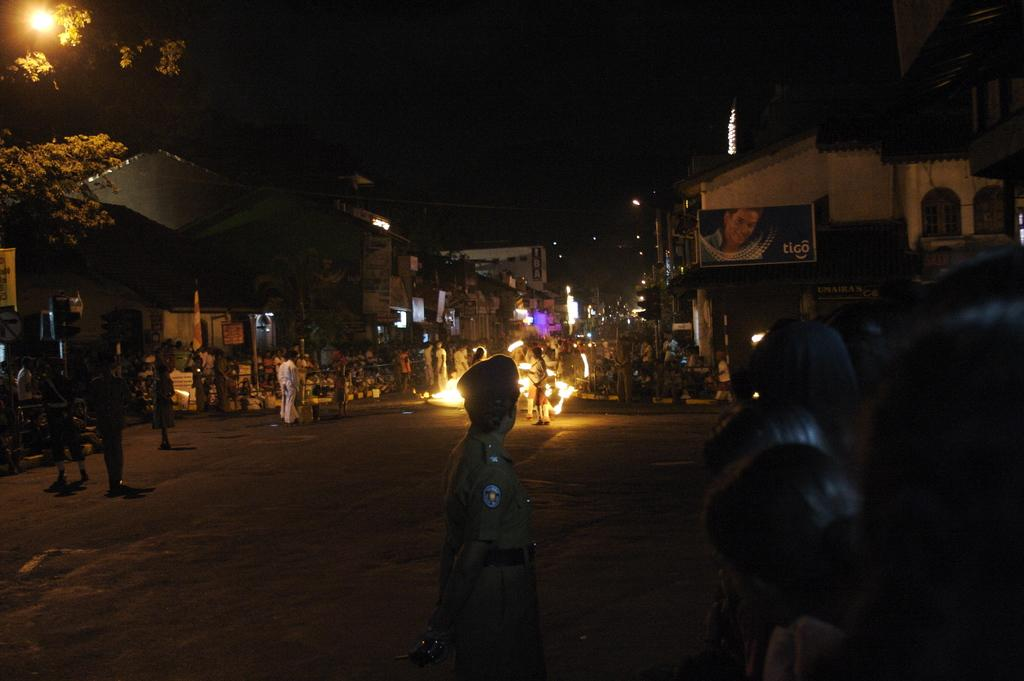What type of structures can be seen in the image? There are buildings in the image. What other natural elements are present in the image? There are trees in the image. What are the light sources on the road in the image? There are light poles in the image. What can be seen on the road in the image? There are people standing on the road in the image. How many apples are hanging from the light poles in the image? There are no apples present in the image, and they are not hanging from the light poles. What type of cord is used to connect the buildings in the image? There is no mention of a cord connecting the buildings in the image. 